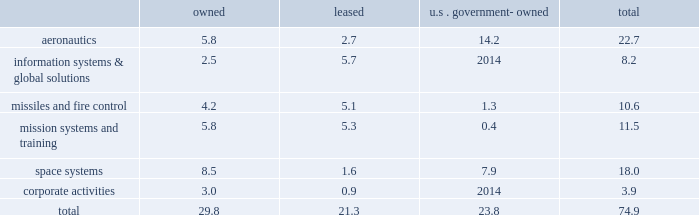Reporting unit 2019s related goodwill assets .
In 2013 , we recorded a non-cash goodwill impairment charge of $ 195 million , net of state tax benefits .
See 201ccritical accounting policies - goodwill 201d in management 2019s discussion and analysis of financial condition and results of operations and 201cnote 1 2013 significant accounting policies 201d for more information on this impairment charge .
Changes in u.s .
Or foreign tax laws , including possibly with retroactive effect , and audits by tax authorities could result in unanticipated increases in our tax expense and affect profitability and cash flows .
For example , proposals to lower the u.s .
Corporate income tax rate would require us to reduce our net deferred tax assets upon enactment of the related tax legislation , with a corresponding material , one-time increase to income tax expense , but our income tax expense and payments would be materially reduced in subsequent years .
Actual financial results could differ from our judgments and estimates .
Refer to 201ccritical accounting policies 201d in management 2019s discussion and analysis of financial condition and results of operations , and 201cnote 1 2013 significant accounting policies 201d of our consolidated financial statements for a complete discussion of our significant accounting policies and use of estimates .
Item 1b .
Unresolved staff comments .
Item 2 .
Properties .
At december 31 , 2013 , we owned or leased building space ( including offices , manufacturing plants , warehouses , service centers , laboratories , and other facilities ) at 518 locations primarily in the u.s .
Additionally , we manage or occupy various u.s .
Government-owned facilities under lease and other arrangements .
At december 31 , 2013 , we had significant operations in the following locations : 2022 aeronautics 2013 palmdale , california ; marietta , georgia ; greenville , south carolina ; fort worth and san antonio , texas ; and montreal , canada .
2022 information systems & global solutions 2013 goodyear , arizona ; sunnyvale , california ; colorado springs and denver , colorado ; gaithersburg and rockville , maryland ; valley forge , pennsylvania ; and houston , texas .
2022 missiles and fire control 2013 camden , arkansas ; orlando , florida ; lexington , kentucky ; and grand prairie , texas .
2022 mission systems and training 2013 orlando , florida ; baltimore , maryland ; moorestown/mt .
Laurel , new jersey ; owego and syracuse , new york ; akron , ohio ; and manassas , virginia .
2022 space systems 2013 huntsville , alabama ; sunnyvale , california ; denver , colorado ; albuquerque , new mexico ; and newtown , pennsylvania .
2022 corporate activities 2013 lakeland , florida and bethesda , maryland .
In november 2013 , we committed to a plan to vacate our leased facilities in goodyear , arizona and akron , ohio , and close our owned facility in newtown , pennsylvania and certain owned buildings at our sunnyvale , california facility .
We expect these closures , which include approximately 2.5 million square feet of facility space , will be substantially complete by the middle of 2015 .
For information regarding these matters , see 201cnote 2 2013 restructuring charges 201d of our consolidated financial statements .
The following is a summary of our square feet of floor space by business segment at december 31 , 2013 , inclusive of the facilities that we plan to vacate as mentioned above ( in millions ) : owned leased u.s .
Government- owned total .
We believe our facilities are in good condition and adequate for their current use .
We may improve , replace , or reduce facilities as considered appropriate to meet the needs of our operations. .
What is the percent of the total aeronautics that is owned? 
Computations: (5.8 / 22.7)
Answer: 0.25551. 